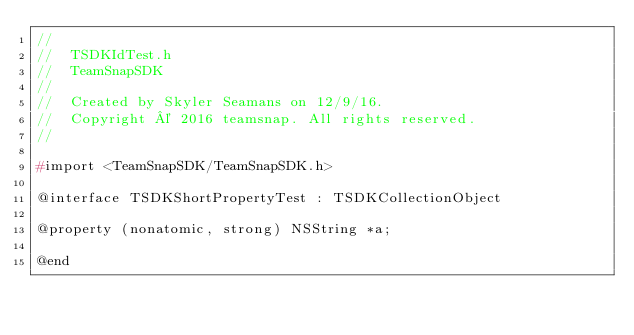<code> <loc_0><loc_0><loc_500><loc_500><_C_>//
//  TSDKIdTest.h
//  TeamSnapSDK
//
//  Created by Skyler Seamans on 12/9/16.
//  Copyright © 2016 teamsnap. All rights reserved.
//

#import <TeamSnapSDK/TeamSnapSDK.h>

@interface TSDKShortPropertyTest : TSDKCollectionObject

@property (nonatomic, strong) NSString *a;

@end
</code> 